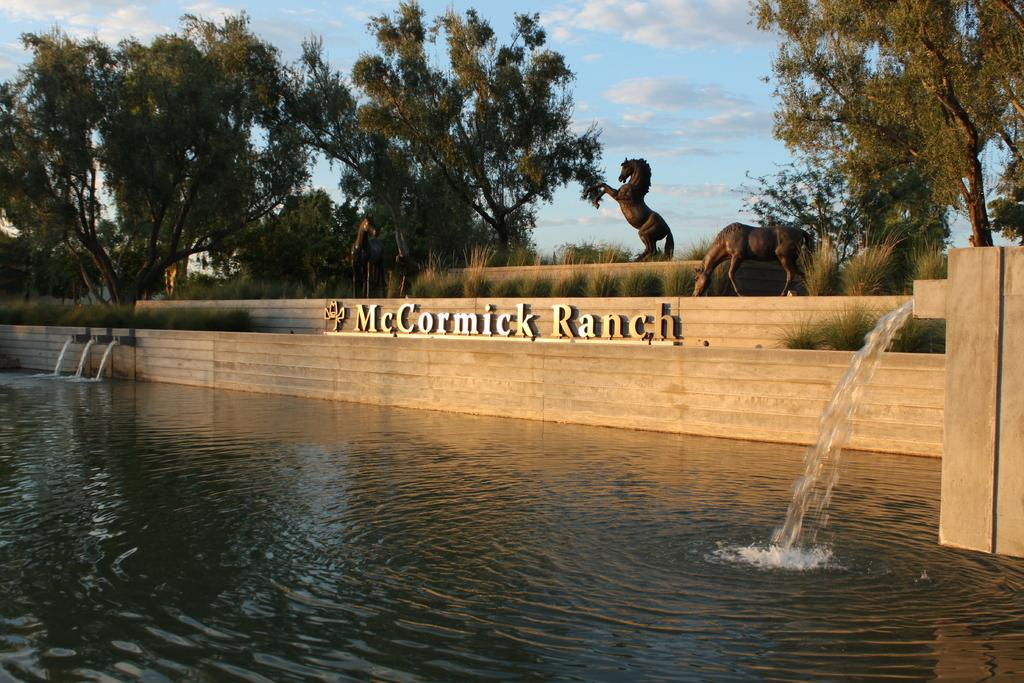What type of vegetation can be seen in the image? There are trees and grass in the image. What natural element is visible in the image? There is water visible in the image. What type of artwork is present in the image? There is a horse sculpture in the image. What is the color of the sky in the image? The sky is blue in the image. What type of riddle can be seen on the horse sculpture in the image? There is no riddle present on the horse sculpture in the image; it is a sculpture of a horse. How many ladybugs are crawling on the grass in the image? There are no ladybugs visible in the image; it only shows trees, grass, water, a horse sculpture, and a blue sky. 